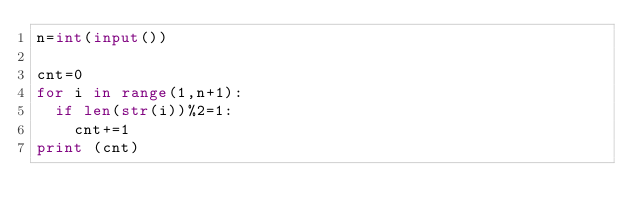Convert code to text. <code><loc_0><loc_0><loc_500><loc_500><_Python_>n=int(input())

cnt=0
for i in range(1,n+1):
  if len(str(i))%2=1:
    cnt+=1
print (cnt)</code> 